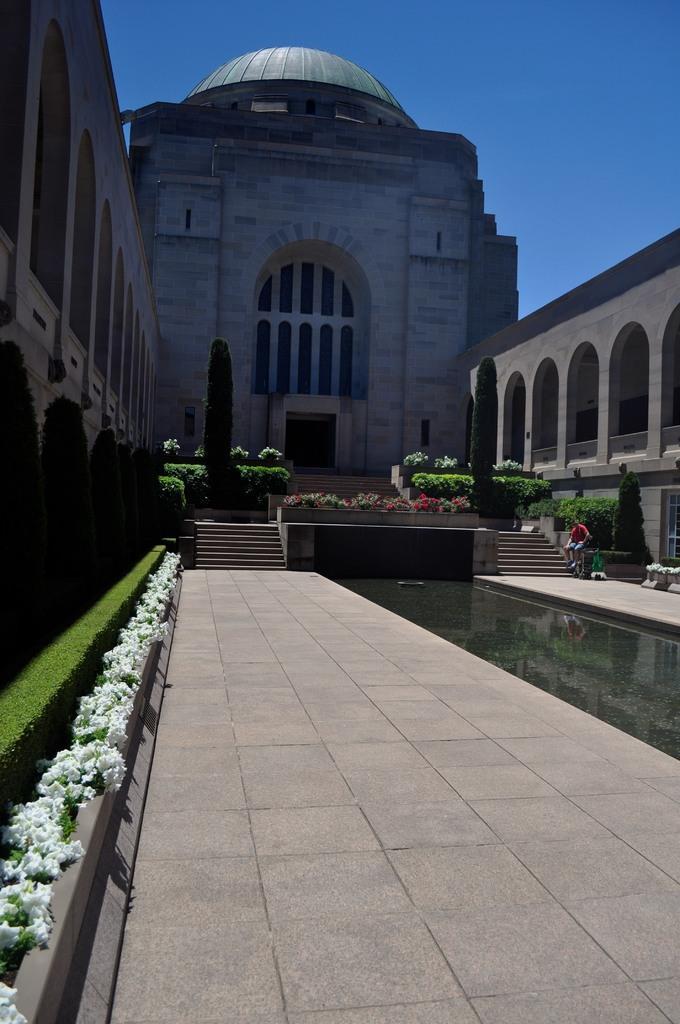How would you summarize this image in a sentence or two? In this image in the center there is a building, on the right side and left side there are some plants, grass and in the center there are some stairs. At the bottom there is a floor, on the left side there are some flowers. At the top of the image there is sky. 